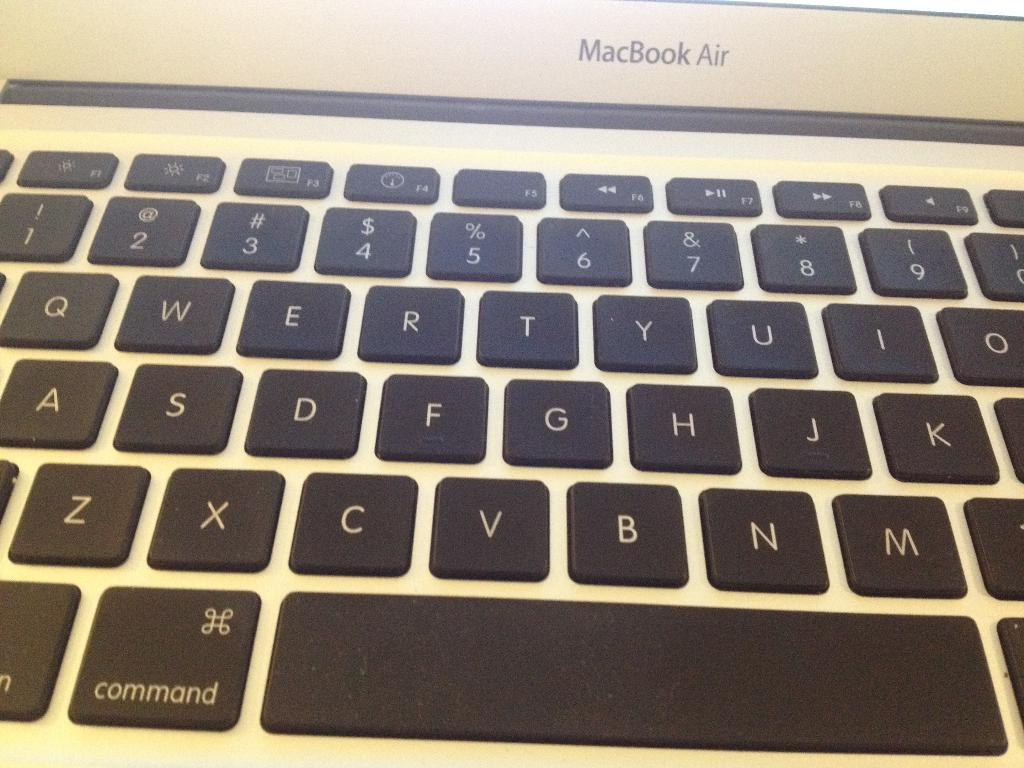What type of device is present in the image? The image contains a keyboard. What kind of buttons are on the keyboard? The keyboard has alphabet buttons and number buttons. What type of art can be seen on the keyboard in the image? There is no art present on the keyboard in the image; it only contains alphabet and number buttons. What shape is the rabbit in the image? There is no rabbit present in the image. 